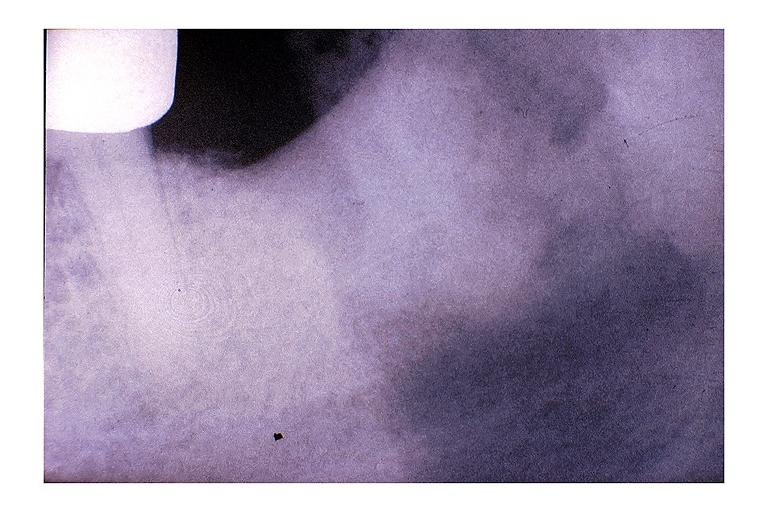what is present?
Answer the question using a single word or phrase. Oral 